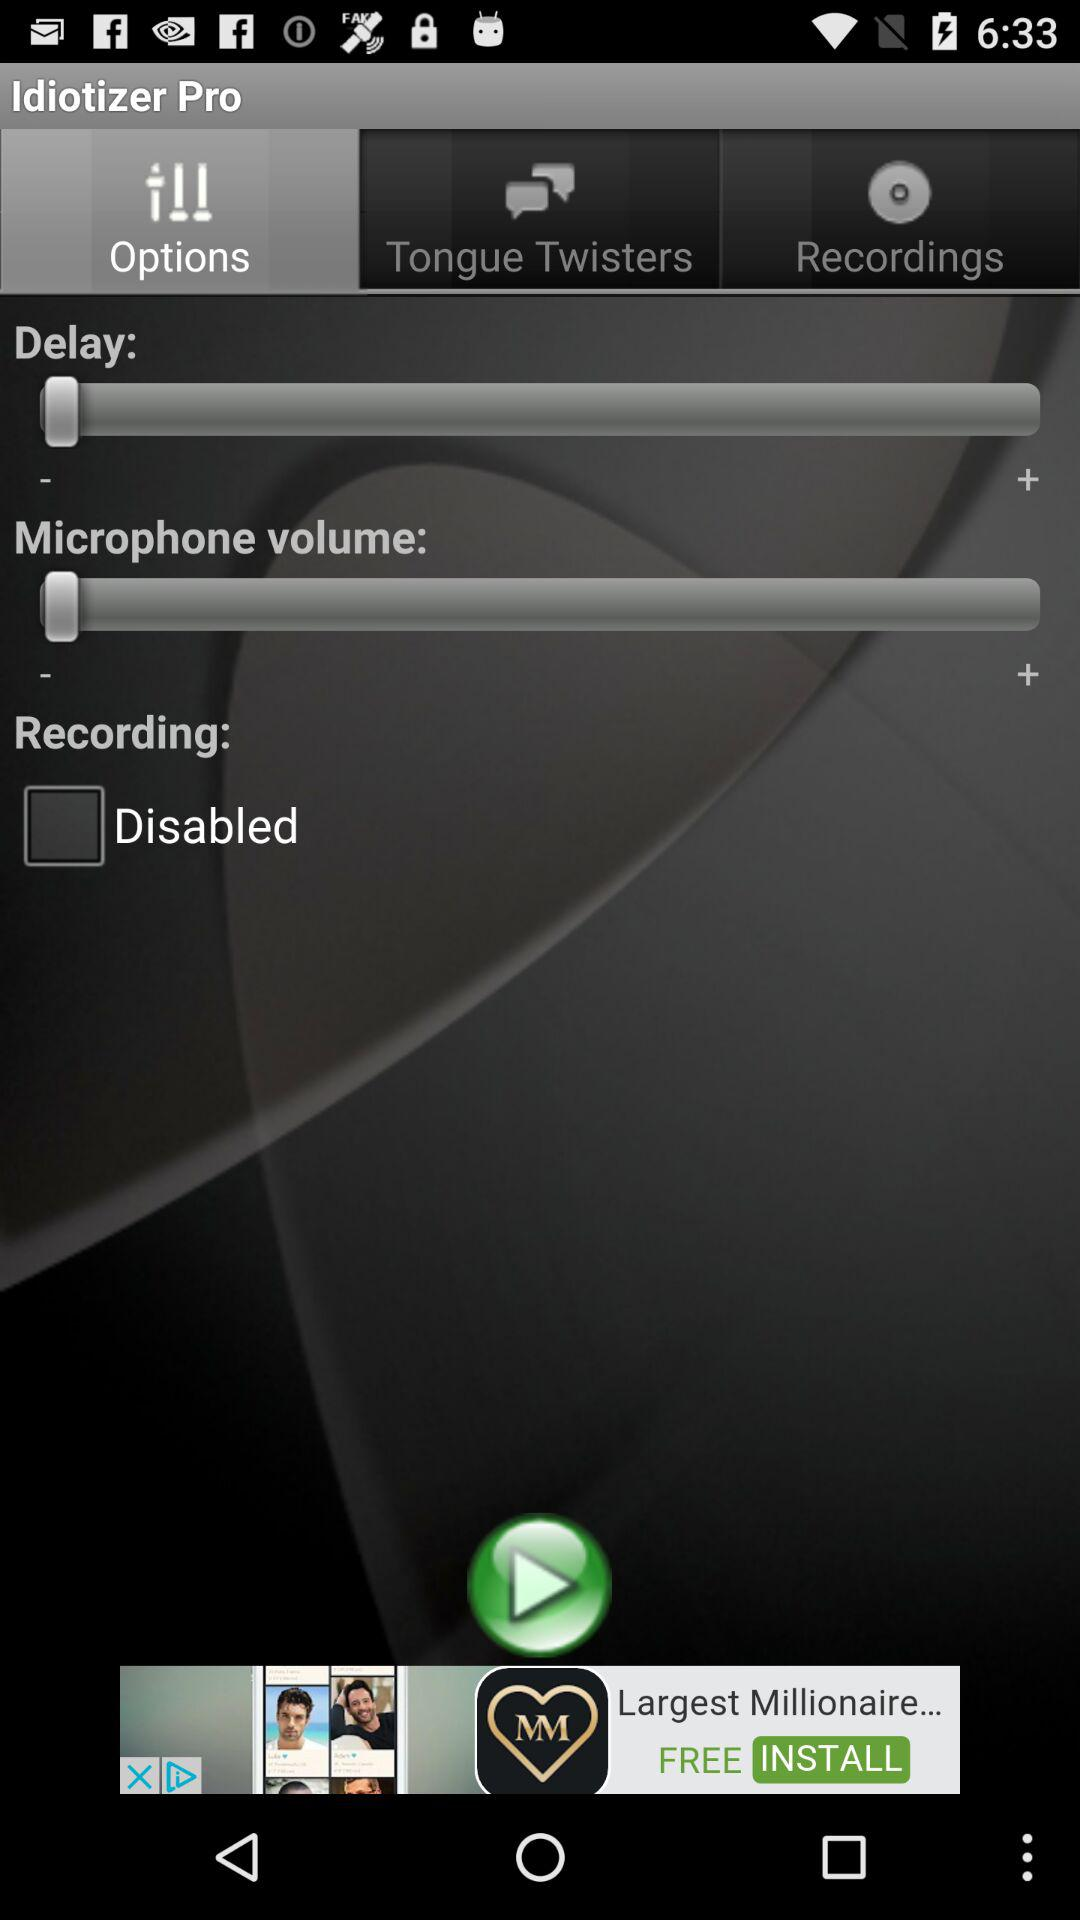What's the status of "Recording"? The status of "Recording" is "Disabled". 